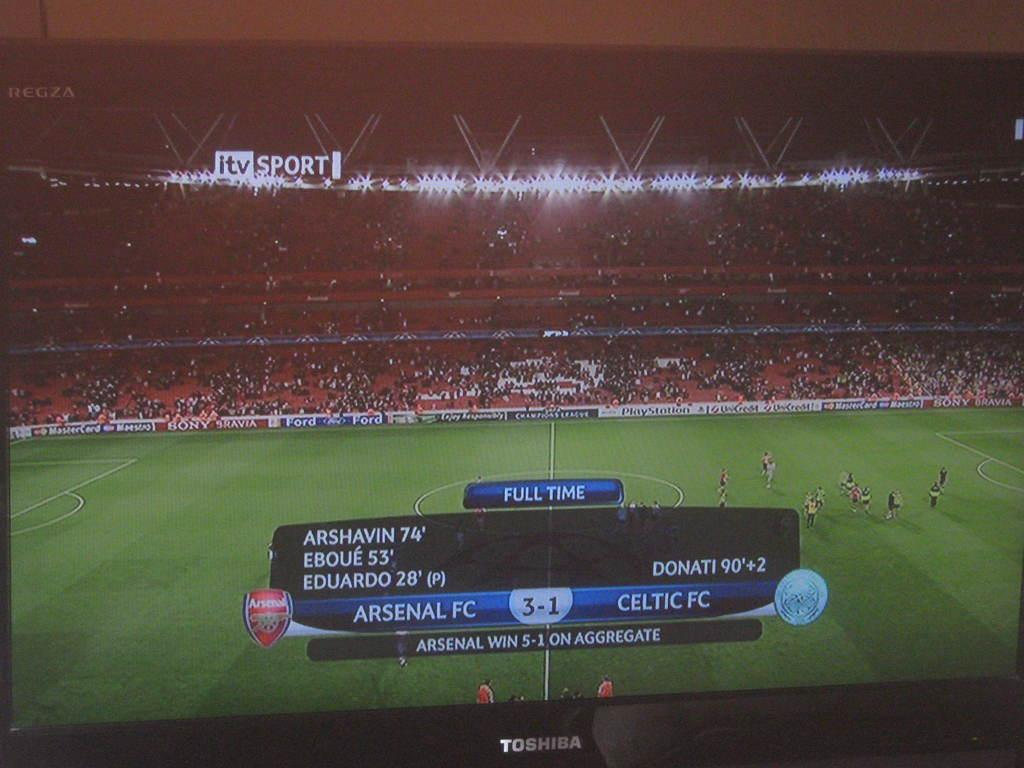Provide a one-sentence caption for the provided image. Arsenal FC beats Celtic FC 3 to 1 in a soccer match on itv Sport. 